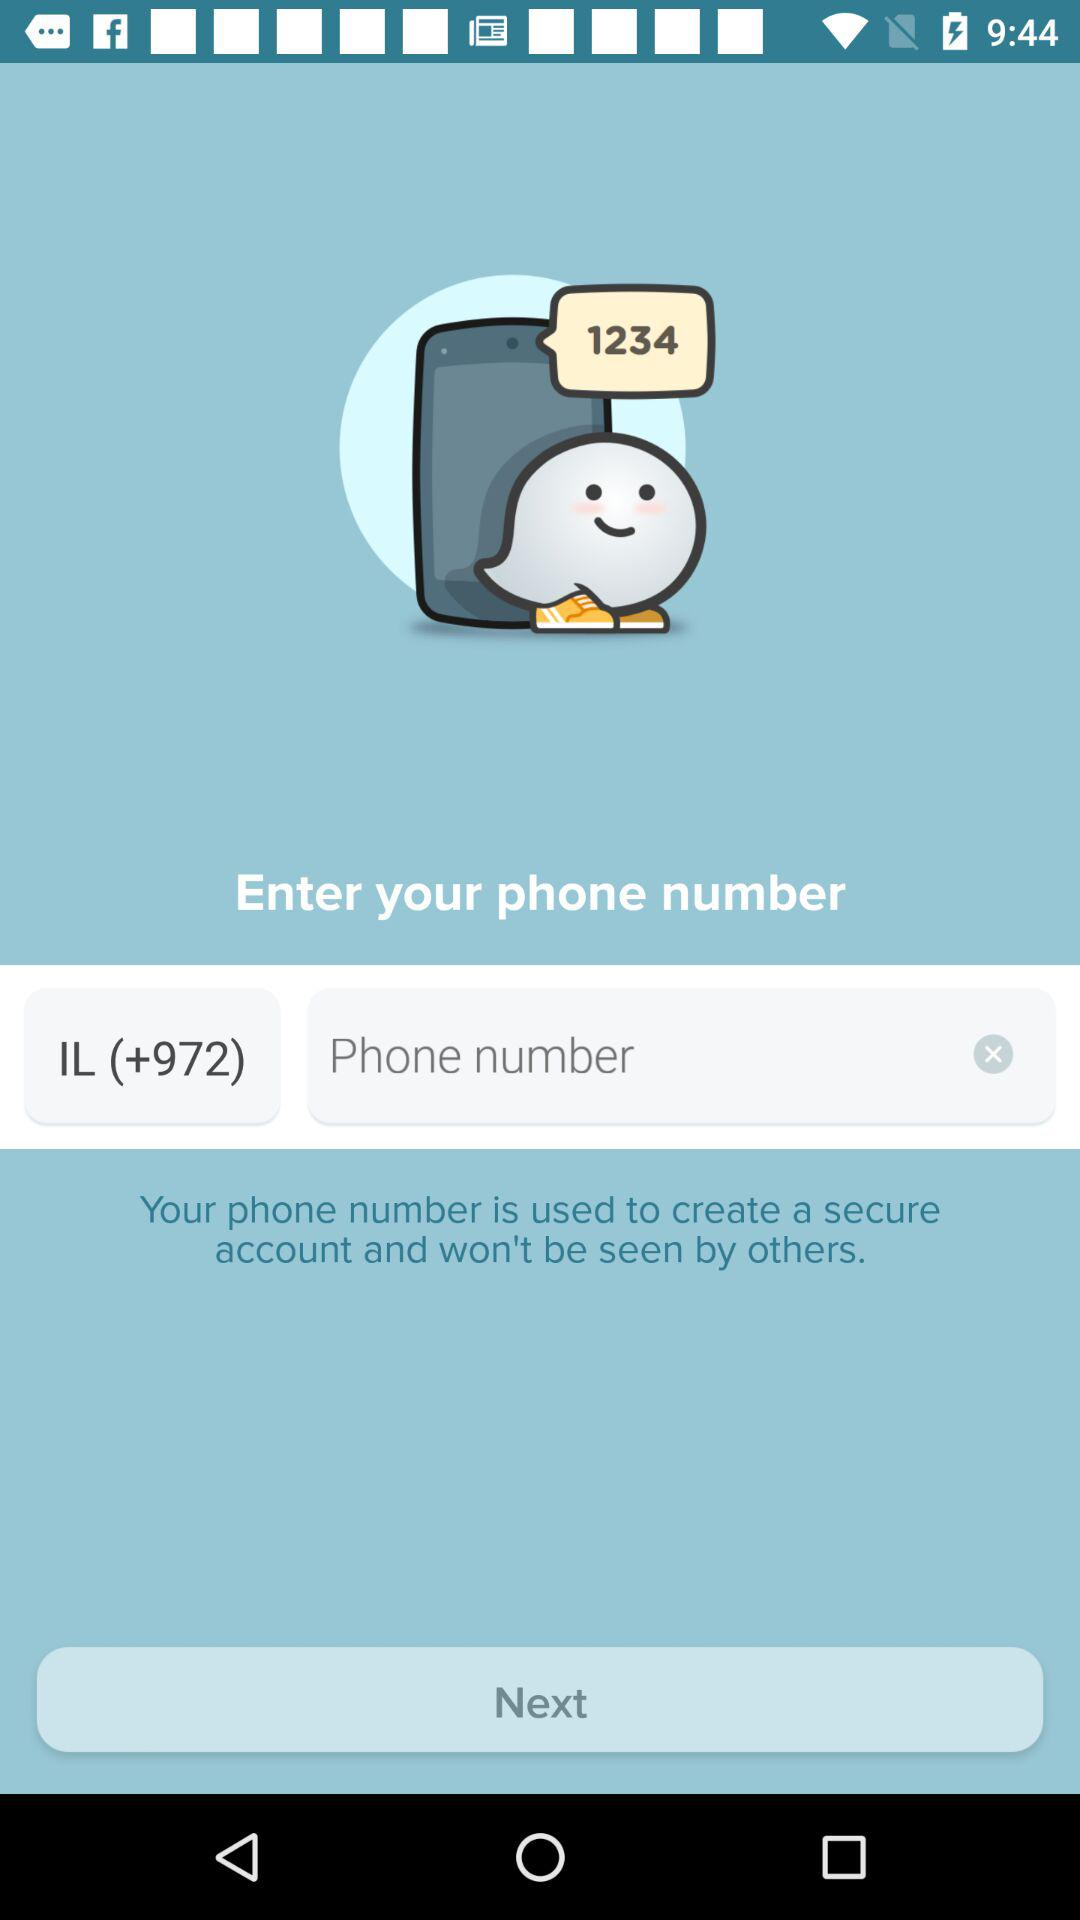What is the user phone number used for? The user phone number is used for creating a secure account. 